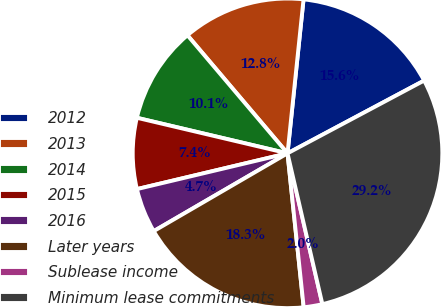Convert chart to OTSL. <chart><loc_0><loc_0><loc_500><loc_500><pie_chart><fcel>2012<fcel>2013<fcel>2014<fcel>2015<fcel>2016<fcel>Later years<fcel>Sublease income<fcel>Minimum lease commitments<nl><fcel>15.56%<fcel>12.84%<fcel>10.12%<fcel>7.4%<fcel>4.67%<fcel>18.28%<fcel>1.95%<fcel>29.17%<nl></chart> 